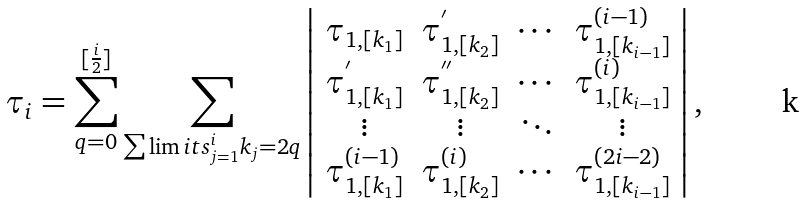Convert formula to latex. <formula><loc_0><loc_0><loc_500><loc_500>\tau _ { i } = \sum ^ { [ \frac { i } { 2 } ] } _ { q = 0 } \sum _ { \sum \lim i t s _ { j = 1 } ^ { i } k _ { j } = 2 q } \left | \begin{array} { c c c c c } \tau _ { 1 , [ k _ { 1 } ] } & \tau ^ { ^ { \prime } } _ { 1 , [ k _ { 2 } ] } & \cdots & \tau ^ { ( i - 1 ) } _ { 1 , [ k _ { i - 1 } ] } \\ \tau ^ { ^ { \prime } } _ { 1 , [ k _ { 1 } ] } & \tau ^ { ^ { \prime \prime } } _ { 1 , [ k _ { 2 } ] } & \cdots & \tau ^ { ( i ) } _ { 1 , [ k _ { i - 1 } ] } \\ \vdots & \vdots & \ddots & \vdots \\ \tau ^ { ( i - 1 ) } _ { 1 , [ k _ { 1 } ] } & \tau ^ { ( i ) } _ { 1 , [ k _ { 2 } ] } & \cdots & \tau ^ { ( 2 i - 2 ) } _ { 1 , [ k _ { i - 1 } ] } \end{array} \right | ,</formula> 